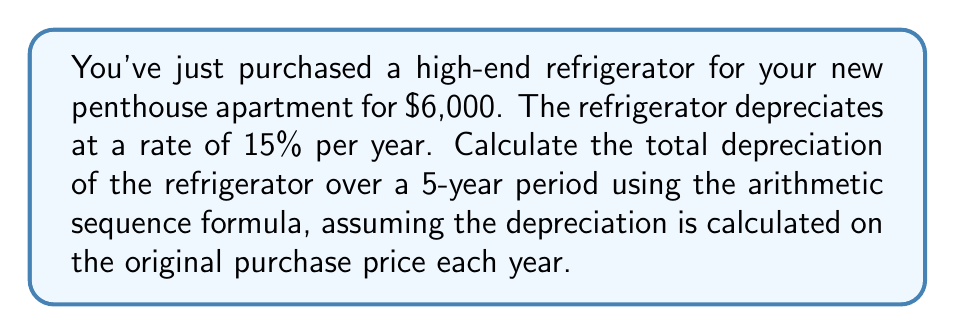Teach me how to tackle this problem. Let's approach this step-by-step:

1) The depreciation amount each year forms an arithmetic sequence.

2) The first term (a₁) is the depreciation in the first year:
   $a_1 = 6000 \times 0.15 = 900$

3) Each subsequent year, the depreciation is the same amount:
   $d = 900$ (common difference)

4) We need to find the sum of this arithmetic sequence for 5 years.

5) The formula for the sum of an arithmetic sequence is:
   $S_n = \frac{n}{2}(a_1 + a_n)$
   where $n$ is the number of terms, $a_1$ is the first term, and $a_n$ is the last term.

6) In this case:
   $n = 5$
   $a_1 = 900$
   $a_5 = a_1$ (since the depreciation is the same each year)

7) Plugging into the formula:
   $S_5 = \frac{5}{2}(900 + 900) = \frac{5}{2}(1800) = 4500$

Therefore, the total depreciation over 5 years is $4,500.
Answer: $4,500 